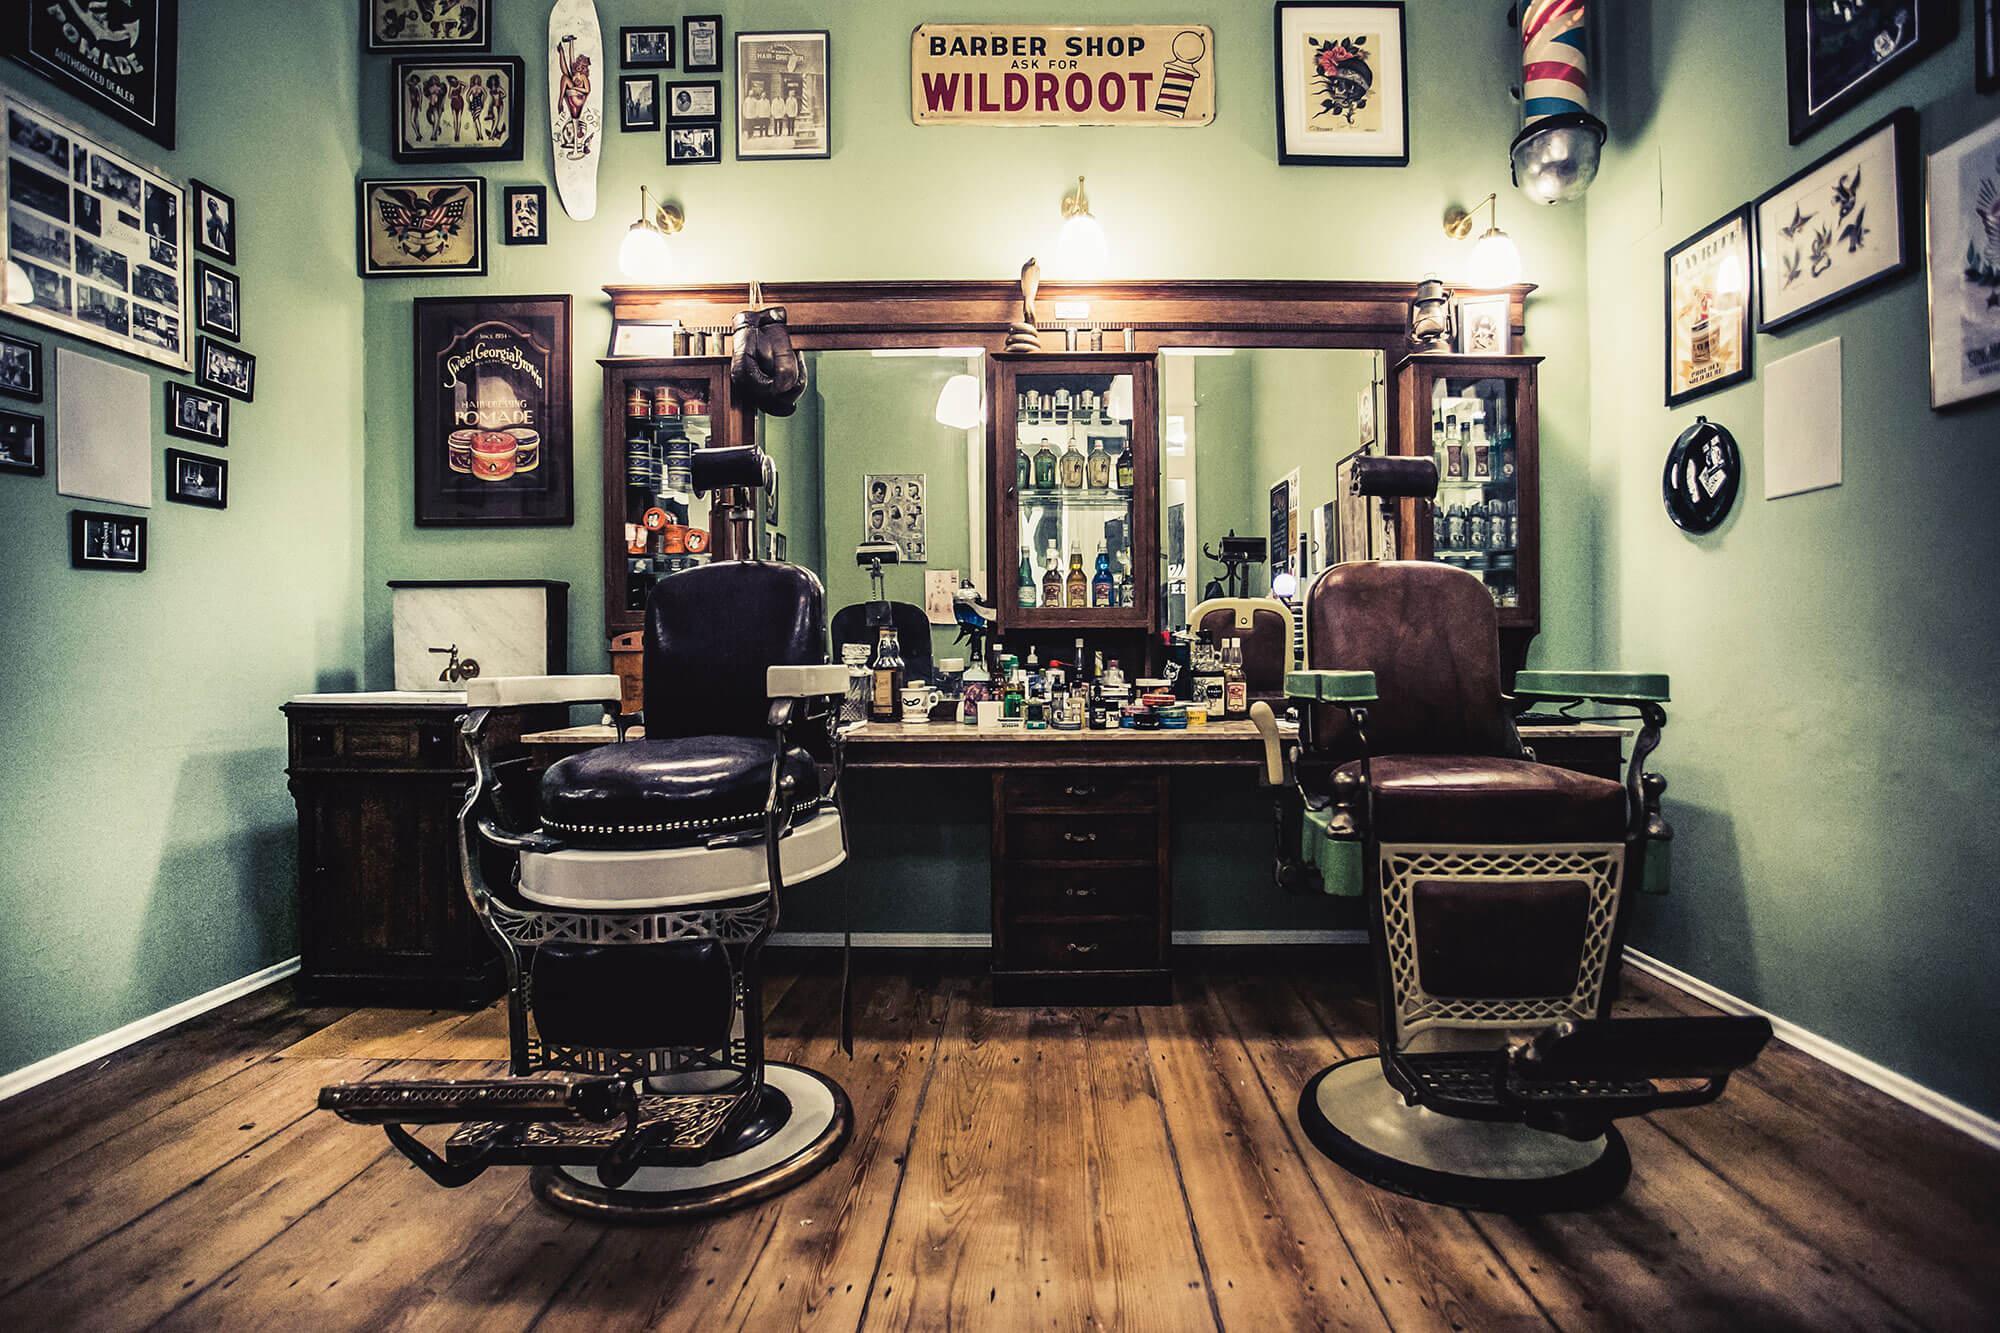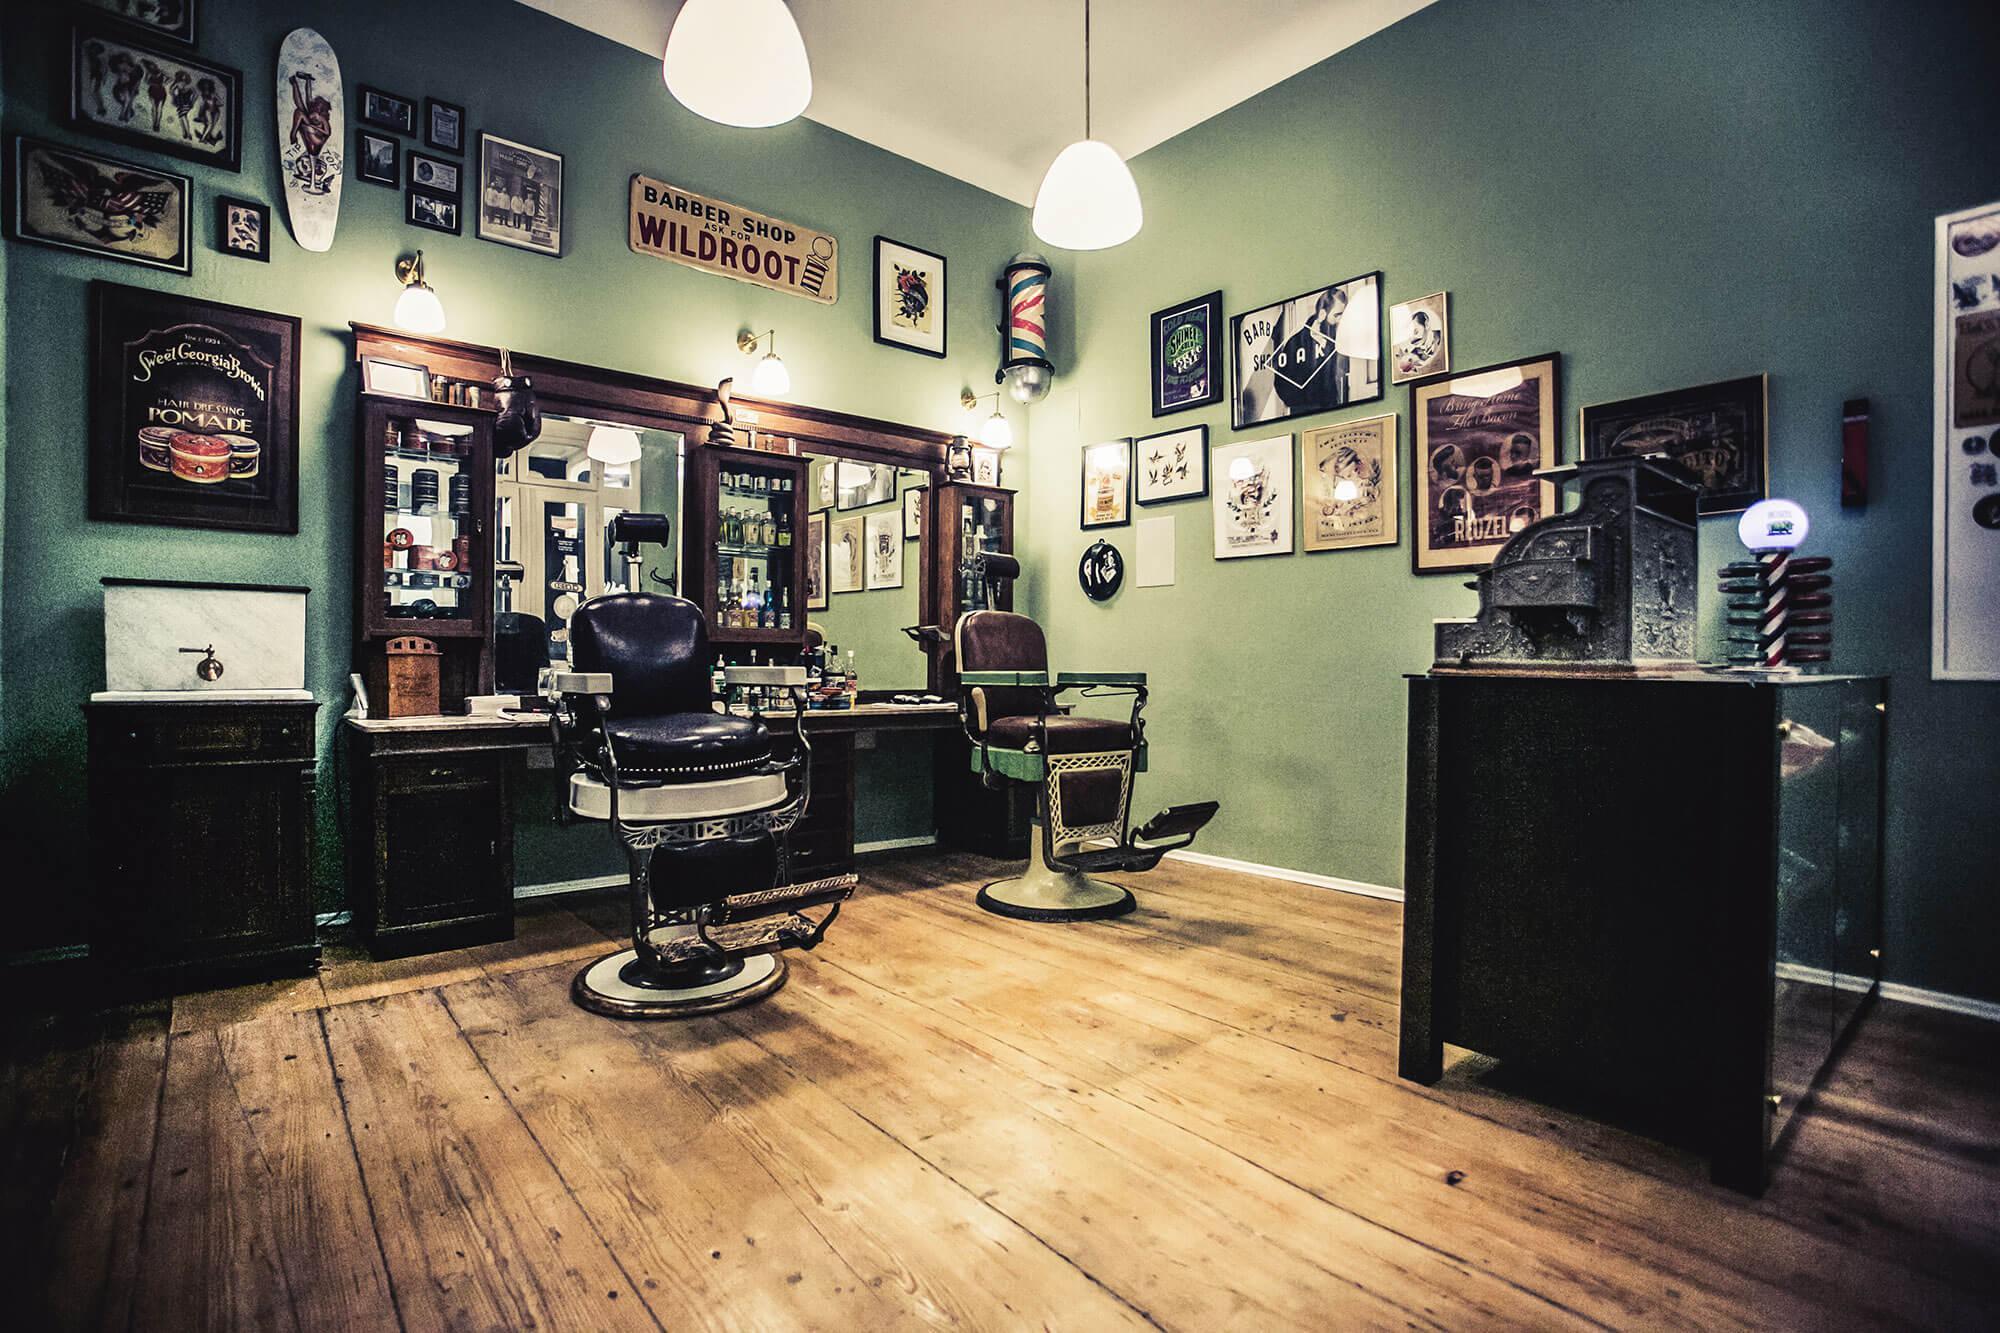The first image is the image on the left, the second image is the image on the right. For the images displayed, is the sentence "There is at least one person at a barber shop." factually correct? Answer yes or no. No. 